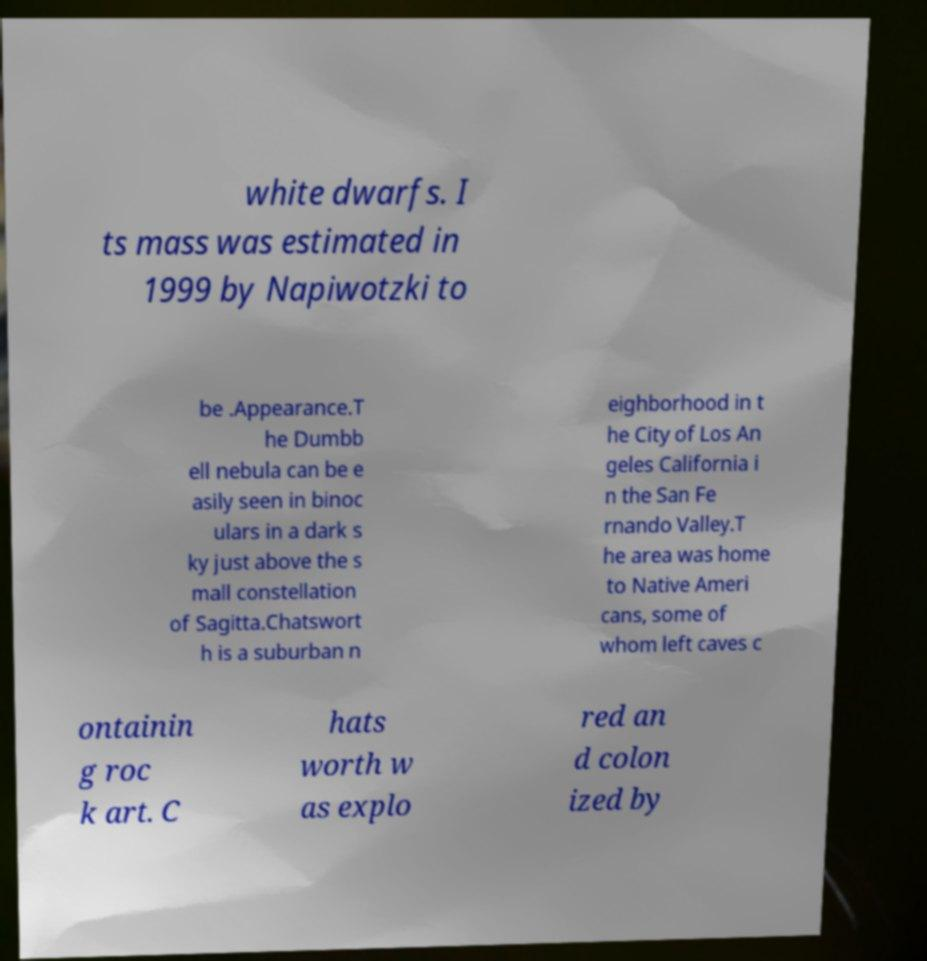For documentation purposes, I need the text within this image transcribed. Could you provide that? white dwarfs. I ts mass was estimated in 1999 by Napiwotzki to be .Appearance.T he Dumbb ell nebula can be e asily seen in binoc ulars in a dark s ky just above the s mall constellation of Sagitta.Chatswort h is a suburban n eighborhood in t he City of Los An geles California i n the San Fe rnando Valley.T he area was home to Native Ameri cans, some of whom left caves c ontainin g roc k art. C hats worth w as explo red an d colon ized by 